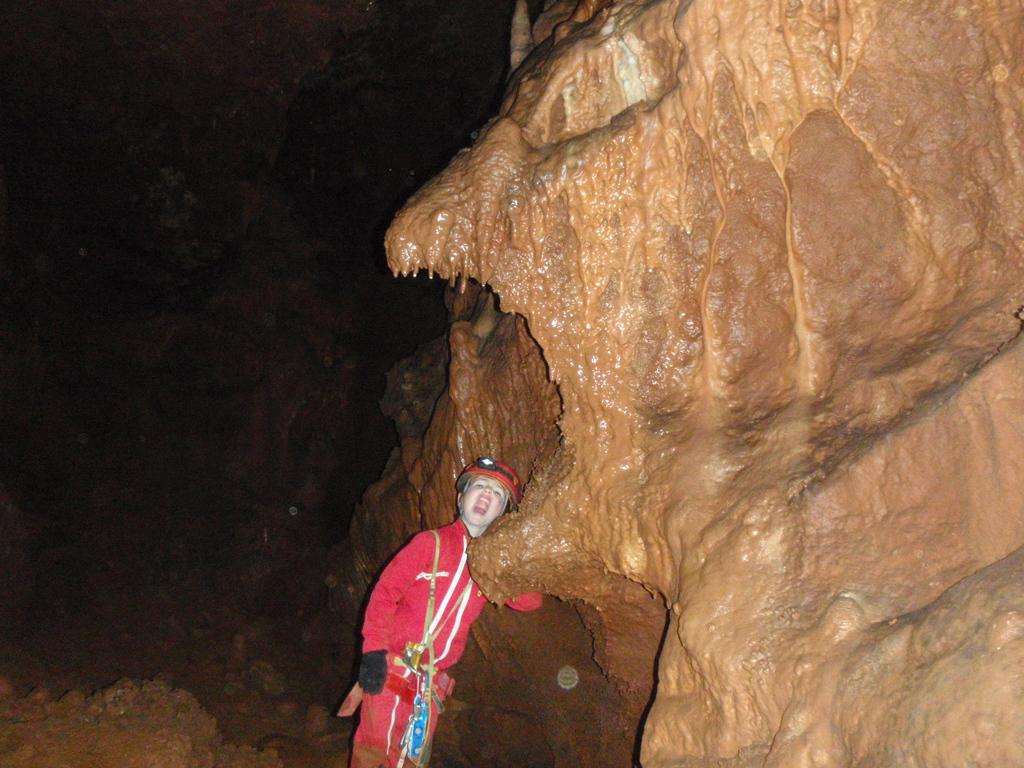What is the main subject of the image? The main subject of the image is a sculpture carved on rocks. Are there any people in the image? Yes, there is a boy in the image. What is the boy wearing? The boy is wearing red color clothes. What is the boy doing in the image? The boy is standing. How many ducks are swimming in the water near the boy in the image? There are no ducks present in the image; it features a sculpture carved on rocks and a boy standing nearby. What type of wind can be seen blowing in the image? There is no wind visible in the image. 